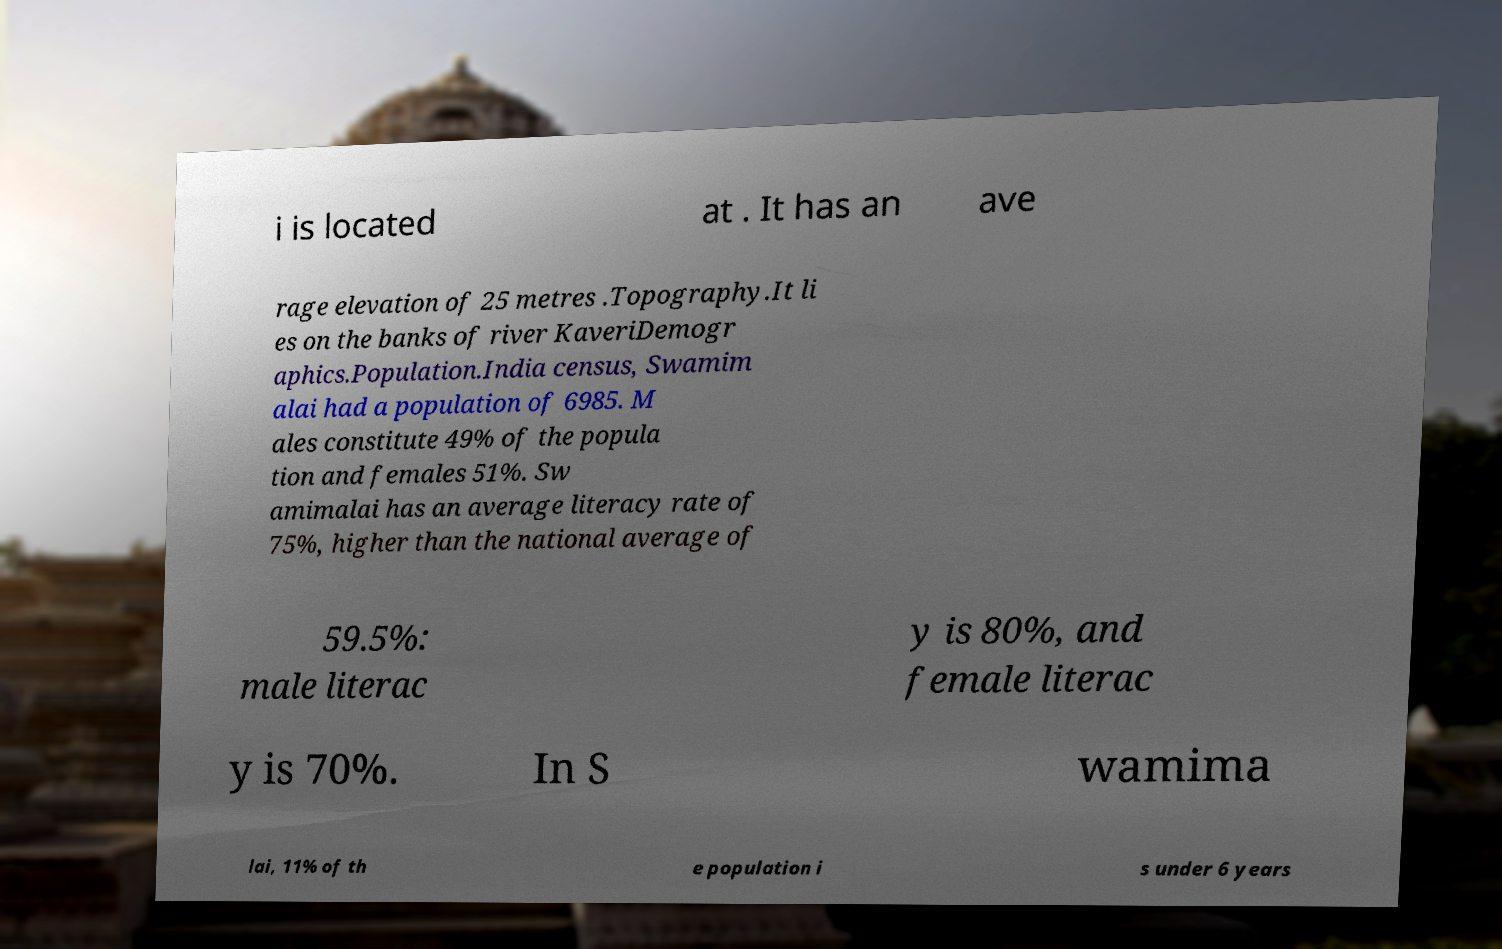What messages or text are displayed in this image? I need them in a readable, typed format. i is located at . It has an ave rage elevation of 25 metres .Topography.It li es on the banks of river KaveriDemogr aphics.Population.India census, Swamim alai had a population of 6985. M ales constitute 49% of the popula tion and females 51%. Sw amimalai has an average literacy rate of 75%, higher than the national average of 59.5%: male literac y is 80%, and female literac y is 70%. In S wamima lai, 11% of th e population i s under 6 years 